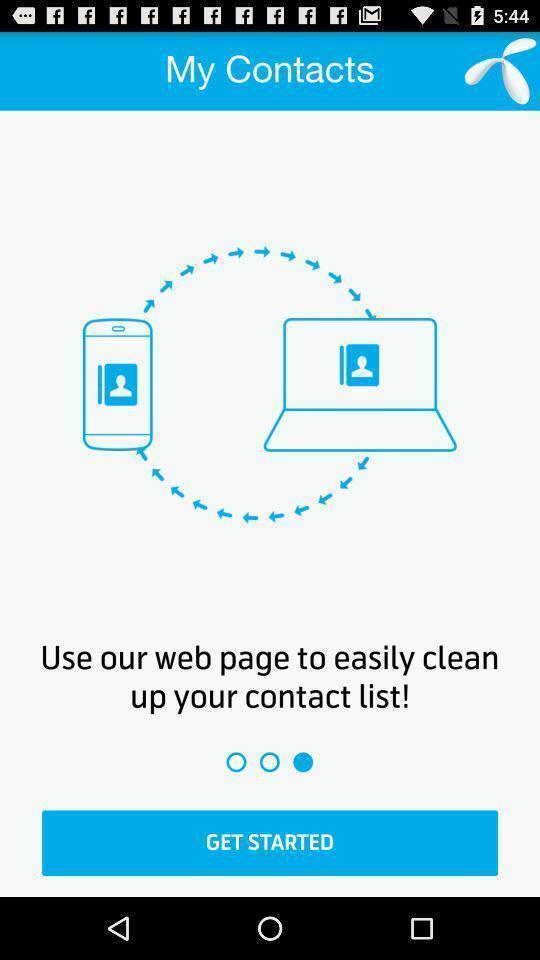Summarize the information in this screenshot. Start page of a contacts backup app. 